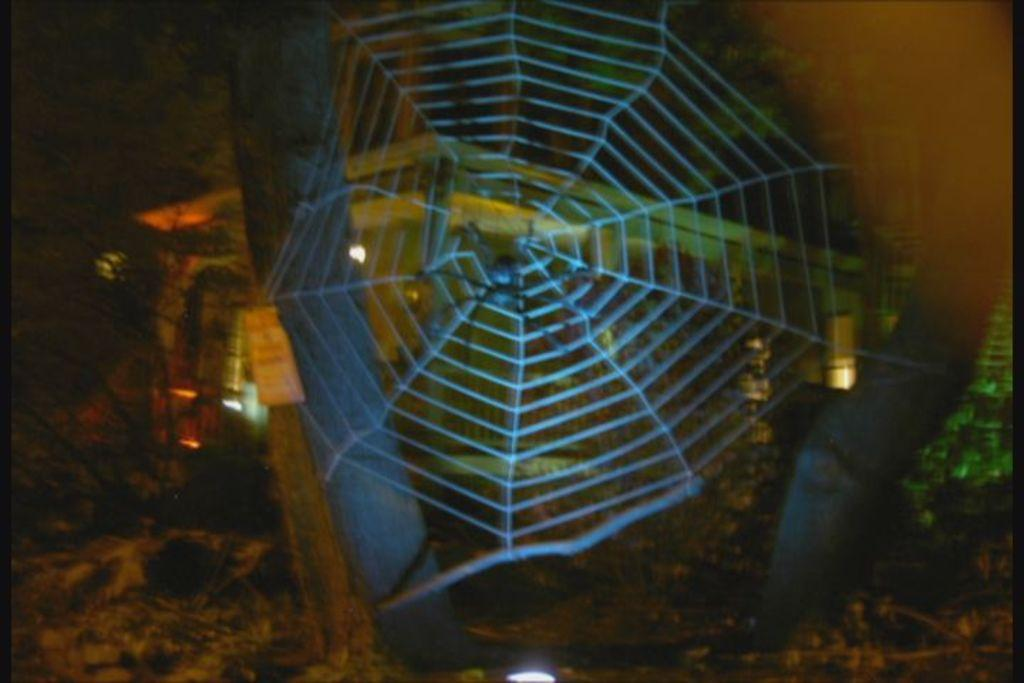What time of day is depicted in the image? The image is a night view. What can be seen in the middle of the image? There is a spider web in the middle of the image. What is visible in the background of the image? There is a house and trees in the background of the image. What type of rod is used to create the rhythm in the image? There is no rod or rhythm present in the image; it is a still image of a spider web at night. 